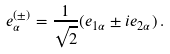Convert formula to latex. <formula><loc_0><loc_0><loc_500><loc_500>e _ { \alpha } ^ { ( \pm ) } = \frac { 1 } { \sqrt { 2 } } ( e _ { 1 \alpha } \pm i e _ { 2 \alpha } ) \, .</formula> 